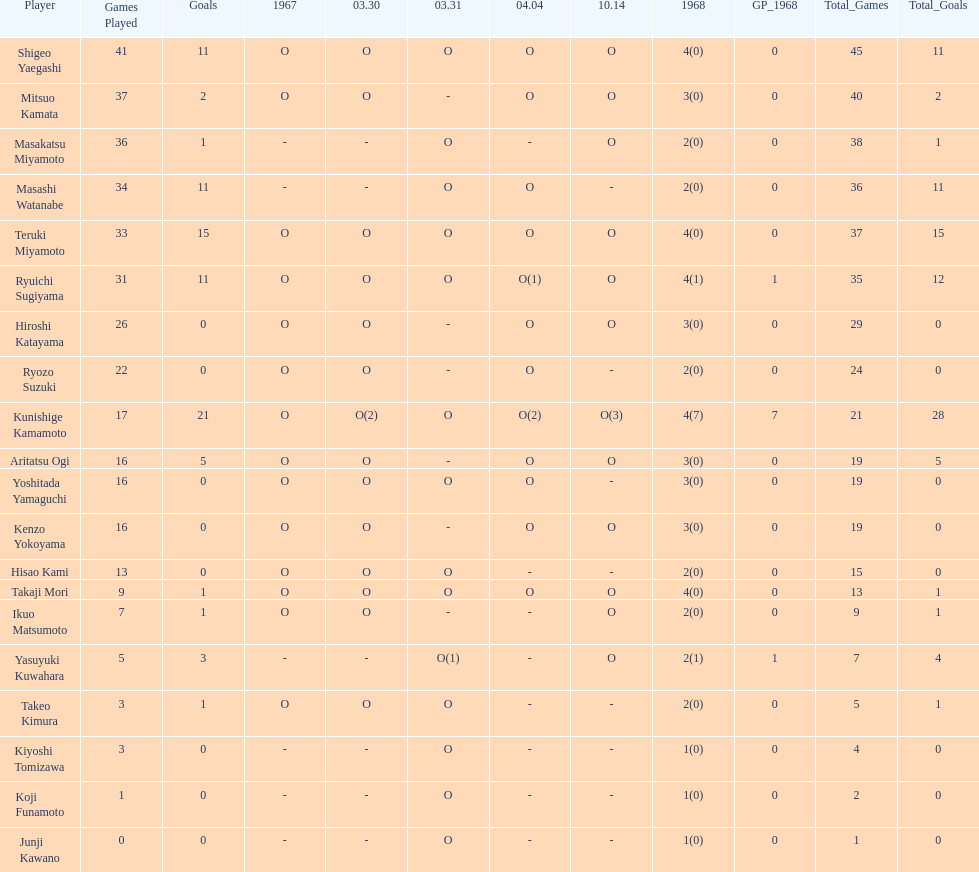Total appearances by masakatsu miyamoto? 38. 